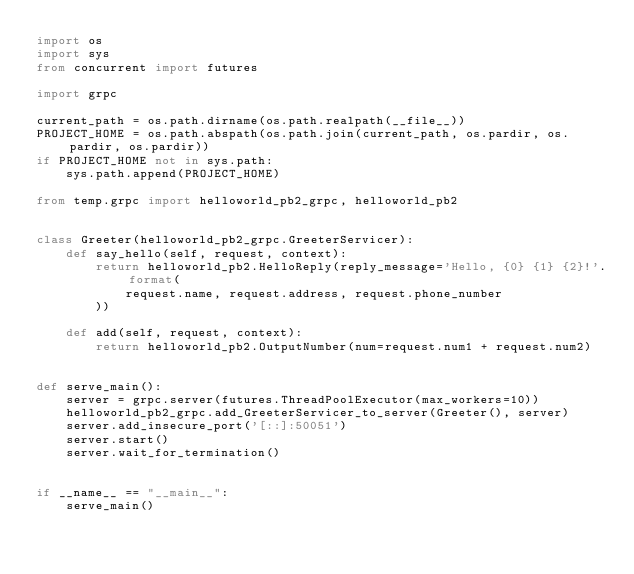<code> <loc_0><loc_0><loc_500><loc_500><_Python_>import os
import sys
from concurrent import futures

import grpc

current_path = os.path.dirname(os.path.realpath(__file__))
PROJECT_HOME = os.path.abspath(os.path.join(current_path, os.pardir, os.pardir, os.pardir))
if PROJECT_HOME not in sys.path:
    sys.path.append(PROJECT_HOME)

from temp.grpc import helloworld_pb2_grpc, helloworld_pb2


class Greeter(helloworld_pb2_grpc.GreeterServicer):
    def say_hello(self, request, context):
        return helloworld_pb2.HelloReply(reply_message='Hello, {0} {1} {2}!'.format(
            request.name, request.address, request.phone_number
        ))

    def add(self, request, context):
        return helloworld_pb2.OutputNumber(num=request.num1 + request.num2)


def serve_main():
    server = grpc.server(futures.ThreadPoolExecutor(max_workers=10))
    helloworld_pb2_grpc.add_GreeterServicer_to_server(Greeter(), server)
    server.add_insecure_port('[::]:50051')
    server.start()
    server.wait_for_termination()


if __name__ == "__main__":
    serve_main()</code> 